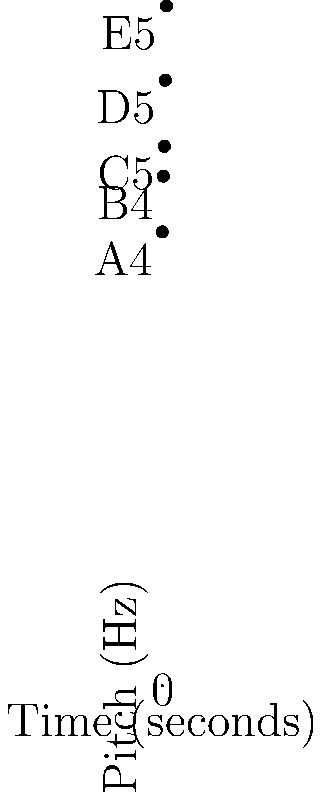As a retired choir member familiar with various musical notations, analyze the given coordinate system where pitch is represented on the y-axis and time on the x-axis. The graph shows a series of notes sung over 4 seconds. What is the interval between the first and last note in this sequence? To determine the interval between the first and last note, we'll follow these steps:

1. Identify the first and last notes:
   - First note (at t=0): A4 (440 Hz)
   - Last note (at t=4): E5 (659 Hz)

2. Recall the standard intervals:
   - Perfect 4th: 4 semitones
   - Perfect 5th: 7 semitones
   - Major 6th: 9 semitones

3. Count the semitones between A4 and E5:
   A4 → B4 (2 semitones)
   B4 → C5 (1 semitone)
   C5 → D5 (2 semitones)
   D5 → E5 (2 semitones)
   Total: 2 + 1 + 2 + 2 = 7 semitones

4. Identify the interval:
   7 semitones correspond to a perfect 5th

Therefore, the interval between the first note (A4) and the last note (E5) is a perfect 5th.
Answer: Perfect 5th 